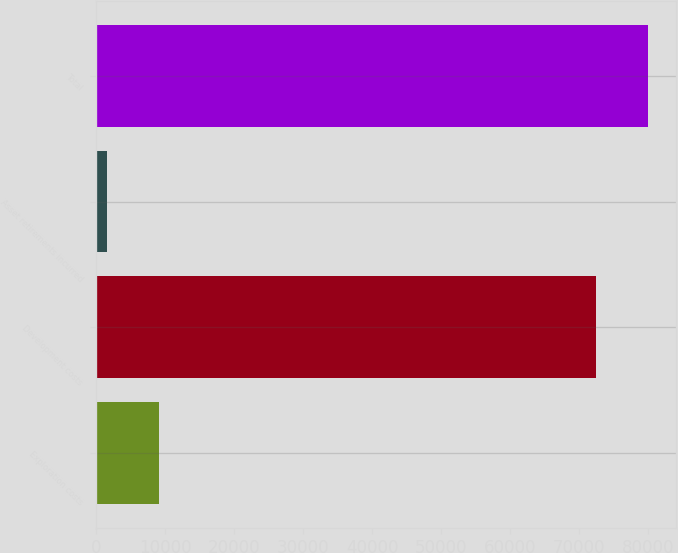<chart> <loc_0><loc_0><loc_500><loc_500><bar_chart><fcel>Exploration costs<fcel>Development costs<fcel>Asset retirements incurred<fcel>Total<nl><fcel>9098.5<fcel>72471<fcel>1568<fcel>80001.5<nl></chart> 